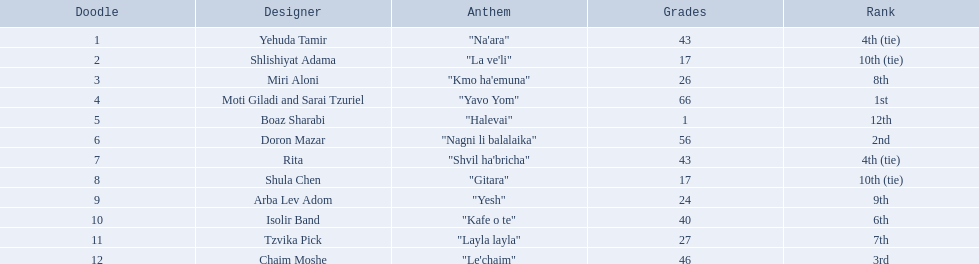Who are all of the artists? Yehuda Tamir, Shlishiyat Adama, Miri Aloni, Moti Giladi and Sarai Tzuriel, Boaz Sharabi, Doron Mazar, Rita, Shula Chen, Arba Lev Adom, Isolir Band, Tzvika Pick, Chaim Moshe. How many points did each score? 43, 17, 26, 66, 1, 56, 43, 17, 24, 40, 27, 46. And which artist had the least amount of points? Boaz Sharabi. 